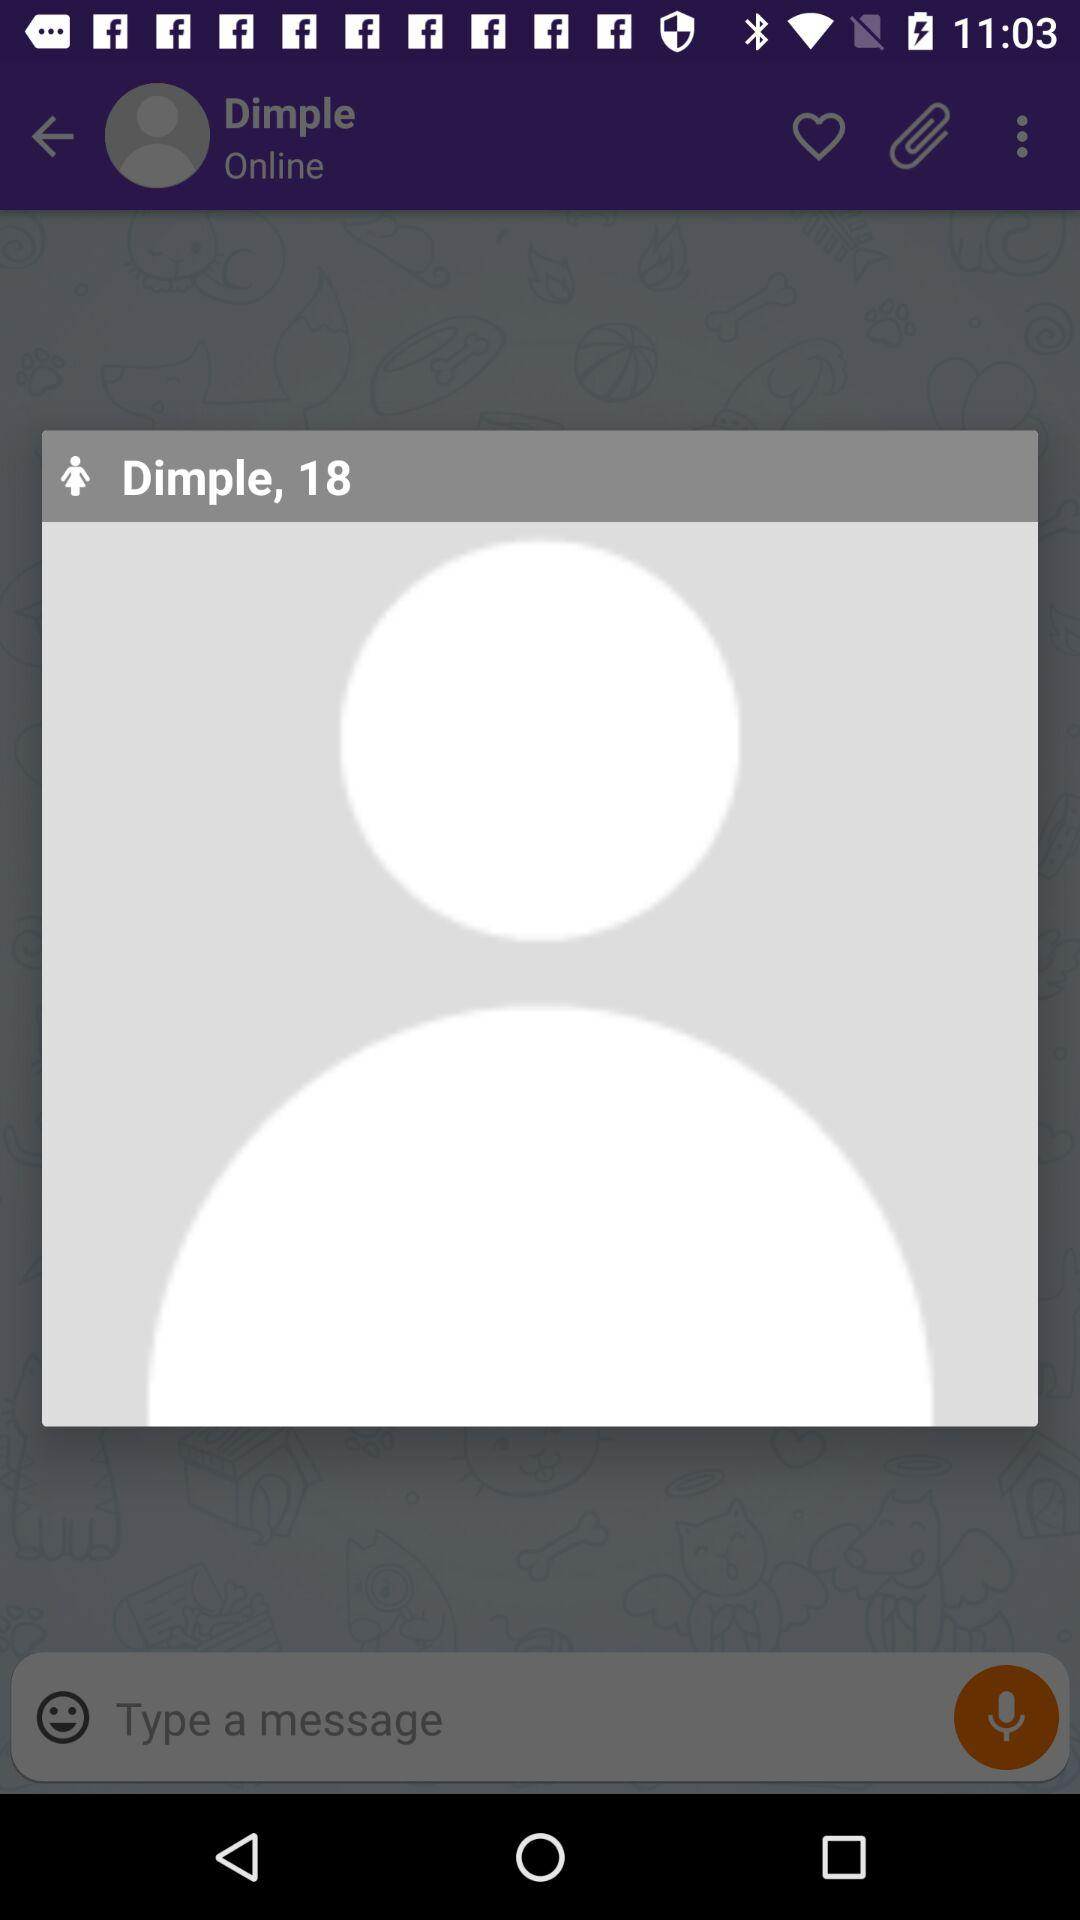What is the age of the user? The age of the user is 18. 